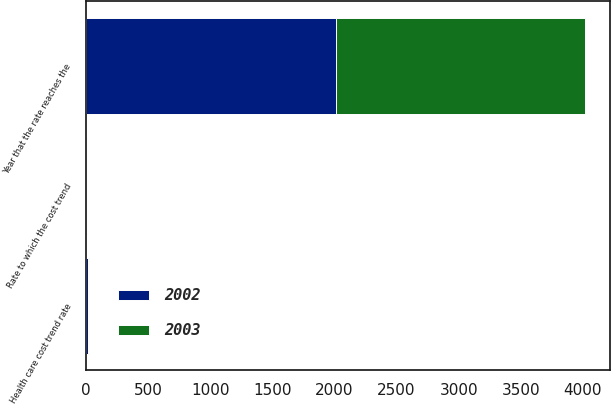Convert chart. <chart><loc_0><loc_0><loc_500><loc_500><stacked_bar_chart><ecel><fcel>Health care cost trend rate<fcel>Rate to which the cost trend<fcel>Year that the rate reaches the<nl><fcel>2003<fcel>9.96<fcel>4.5<fcel>2010<nl><fcel>2002<fcel>10.88<fcel>4.48<fcel>2010<nl></chart> 